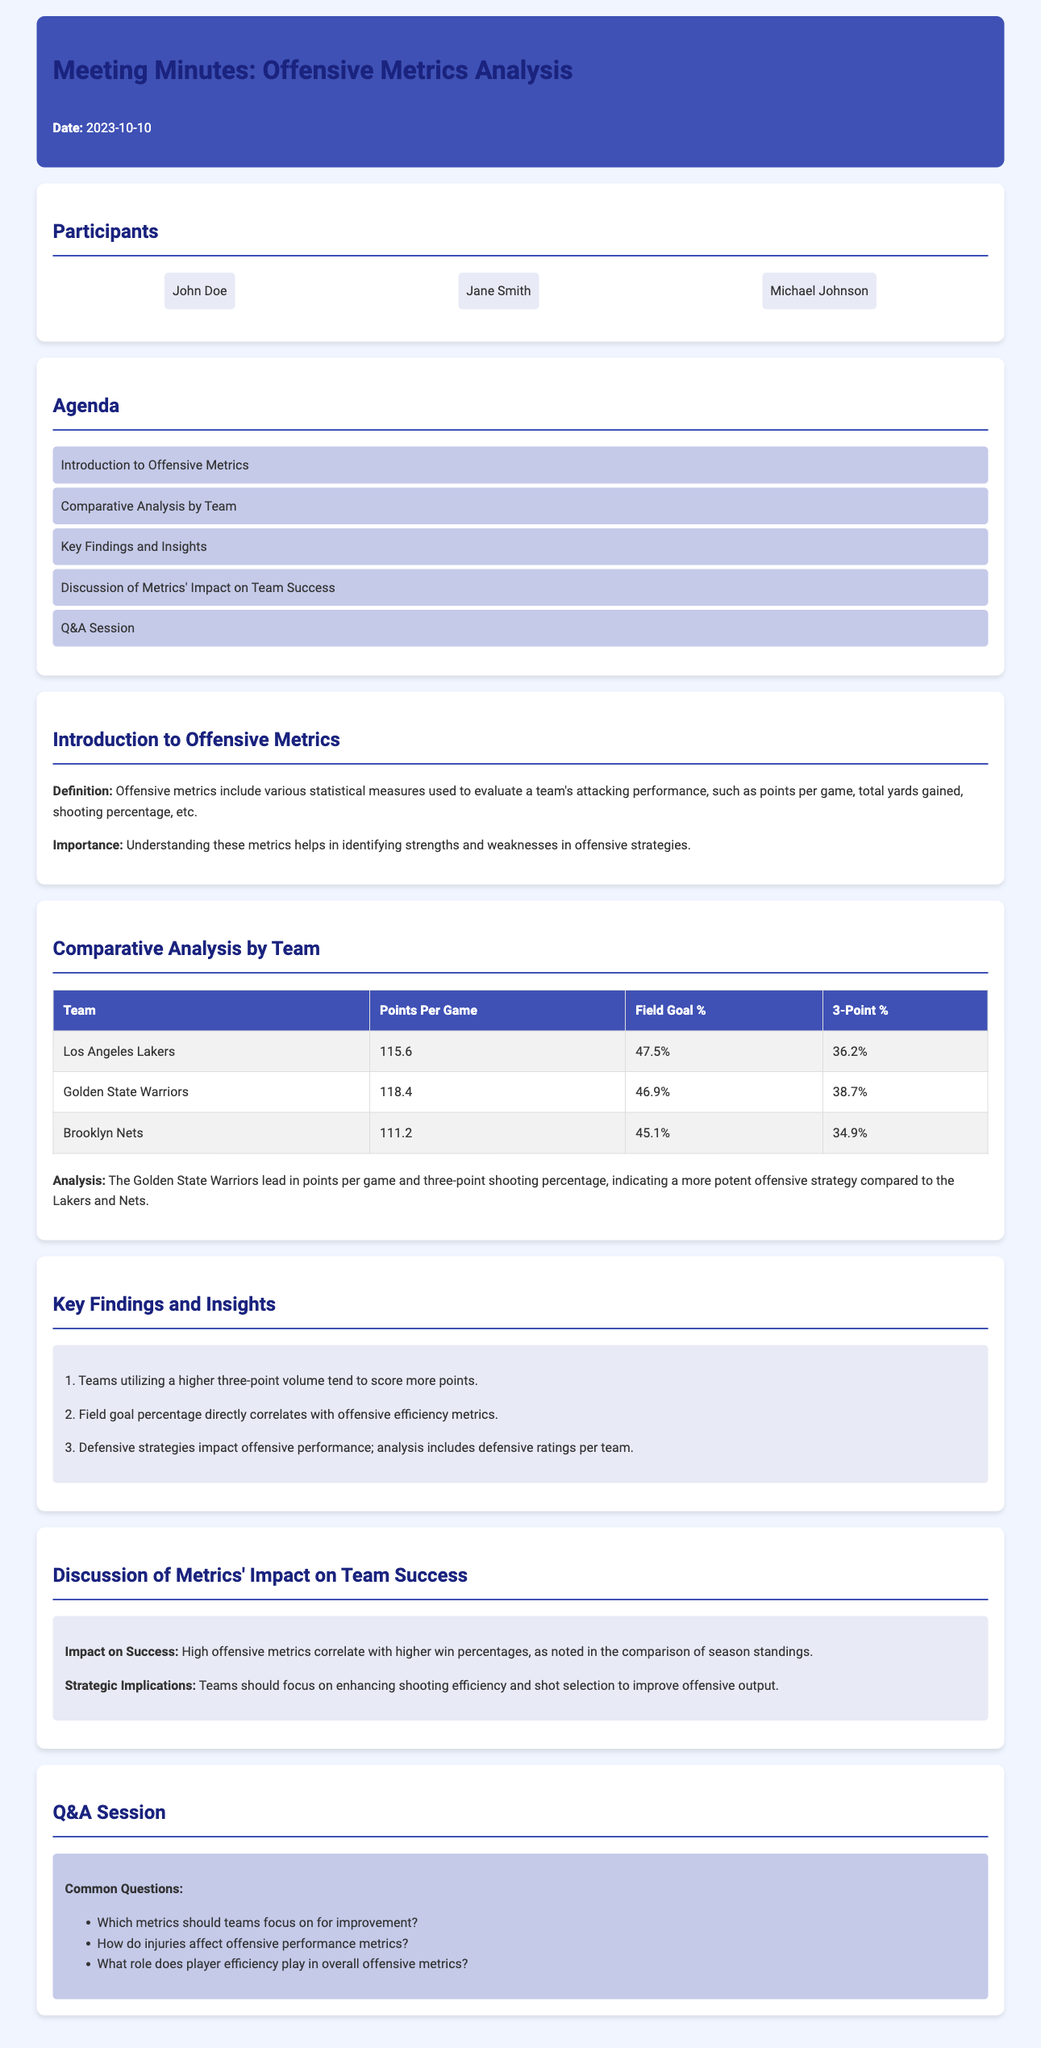What is the date of the meeting? The date of the meeting is specified in the document under the header, which is 2023-10-10.
Answer: 2023-10-10 Who presented the analysis? The participants in the meeting include John Doe, Jane Smith, and Michael Johnson as noted in the participants section.
Answer: John Doe What is the points per game for the Golden State Warriors? The points per game for the Golden State Warriors is provided in the comparative analysis table, which is 118.4.
Answer: 118.4 What was highlighted about teams with higher three-point volumes? The document mentions a key finding that teams utilizing a higher three-point volume tend to score more points.
Answer: Score more points How does field goal percentage relate to offensive efficiency? The document states a correlation between field goal percentage and offensive efficiency metrics in the key findings.
Answer: Directly correlates What is the primary topic of discussion in the meeting? The main topic of discussion concerns the metrics' impact on team success, specifically how high offensive metrics correlate with higher win percentages.
Answer: Metrics' impact on team success Which team has the highest field goal percentage? The comparative analysis indicates that the Los Angeles Lakers have the highest field goal percentage at 47.5%.
Answer: 47.5% What role does player efficiency play in offensive metrics? This is a question raised during the Q&A session of the meeting, implying it is a topic of interest for further discussion.
Answer: Role of player efficiency What does the introduction specify as the importance of understanding offensive metrics? The introduction emphasizes that understanding these metrics helps in identifying strengths and weaknesses in offensive strategies.
Answer: Identifying strengths and weaknesses 